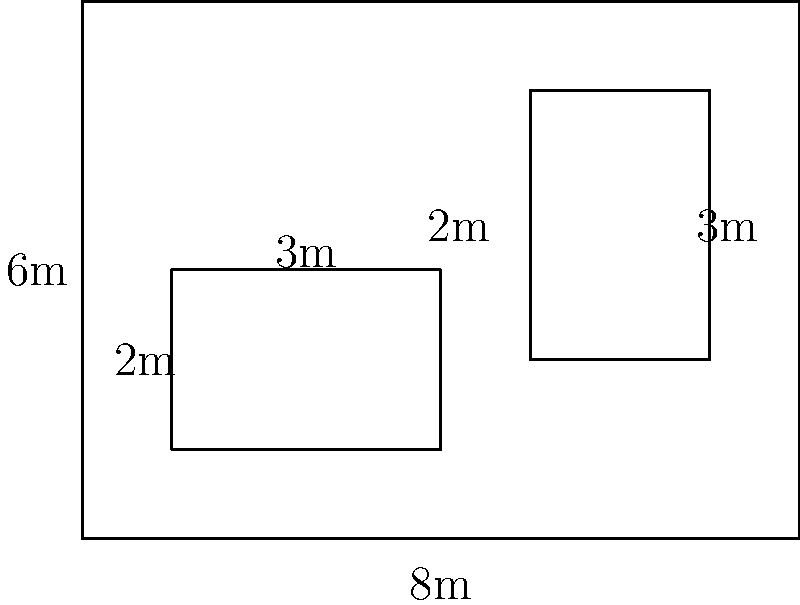In an Ethiopian Orthodox monastery, the main compound is rectangular with dimensions 8m by 6m. Within this compound, there are two smaller chapels: one measuring 3m by 2m and another measuring 2m by 3m, as shown in the diagram. Calculate the total floor area of the monastery that is not occupied by the chapels. Express your answer in square meters. Let's approach this step-by-step:

1) First, calculate the total area of the monastery compound:
   $$A_{total} = 8m \times 6m = 48m^2$$

2) Now, calculate the areas of the two chapels:
   Chapel 1: $$A_{chapel1} = 3m \times 2m = 6m^2$$
   Chapel 2: $$A_{chapel2} = 2m \times 3m = 6m^2$$

3) The total area occupied by the chapels is:
   $$A_{chapels} = A_{chapel1} + A_{chapel2} = 6m^2 + 6m^2 = 12m^2$$

4) The area we're looking for is the difference between the total area and the area occupied by the chapels:
   $$A_{free} = A_{total} - A_{chapels} = 48m^2 - 12m^2 = 36m^2$$

Therefore, the total floor area of the monastery not occupied by the chapels is 36 square meters.
Answer: 36m² 